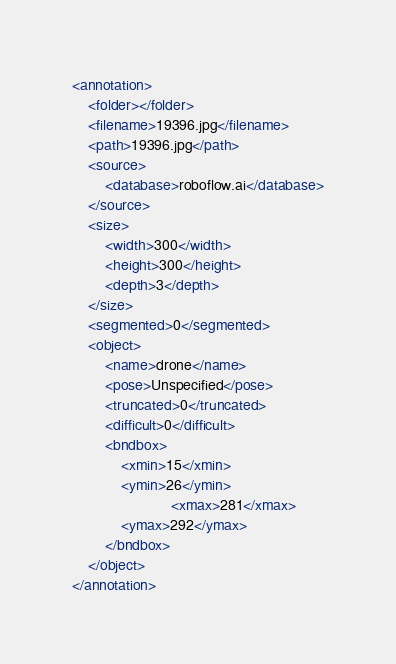<code> <loc_0><loc_0><loc_500><loc_500><_XML_><annotation>
	<folder></folder>
	<filename>19396.jpg</filename>
	<path>19396.jpg</path>
	<source>
		<database>roboflow.ai</database>
	</source>
	<size>
		<width>300</width>
		<height>300</height>
		<depth>3</depth>
	</size>
	<segmented>0</segmented>
	<object>
		<name>drone</name>
		<pose>Unspecified</pose>
		<truncated>0</truncated>
		<difficult>0</difficult>
		<bndbox>
			<xmin>15</xmin>
			<ymin>26</ymin>
                        <xmax>281</xmax>
			<ymax>292</ymax>
		</bndbox>
	</object>
</annotation>
</code> 